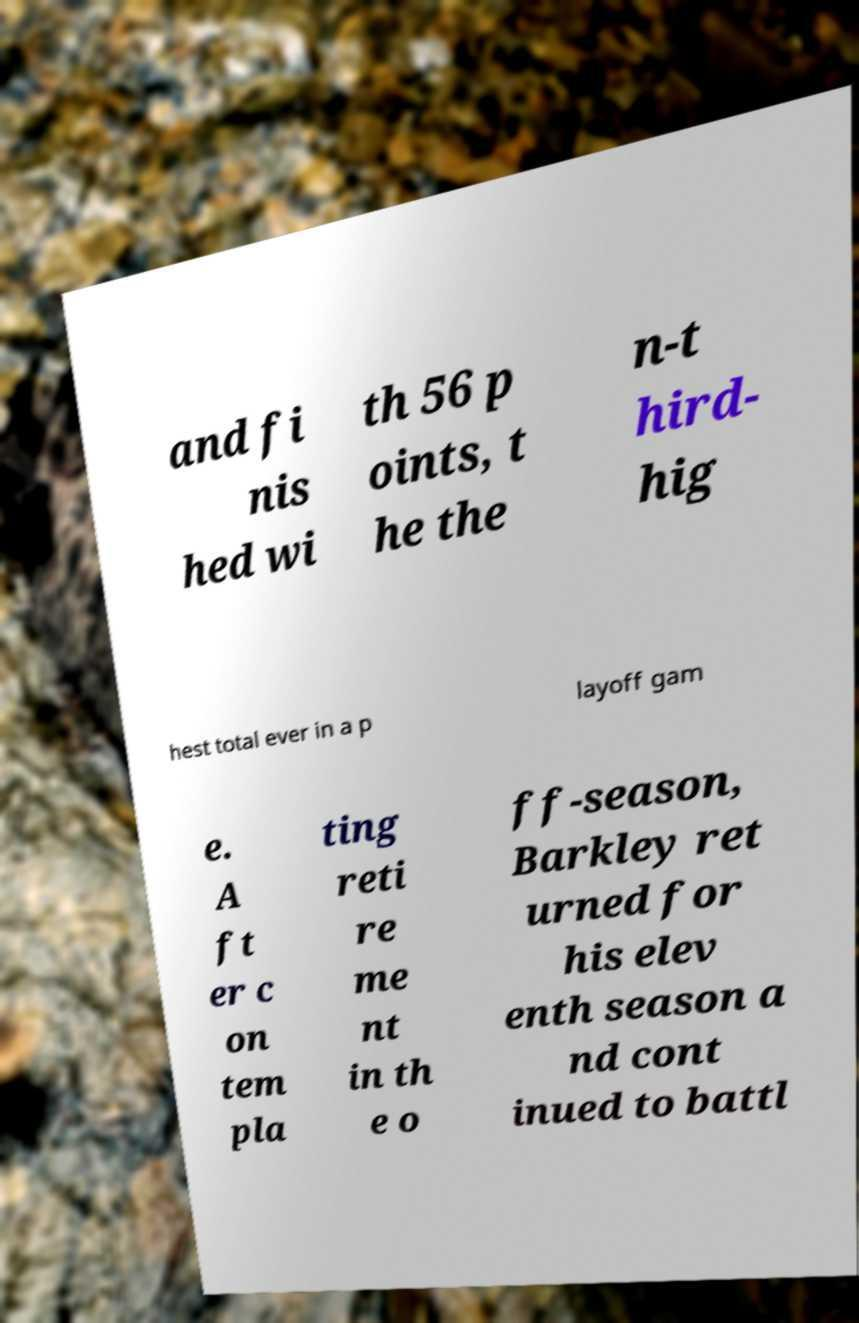Could you assist in decoding the text presented in this image and type it out clearly? and fi nis hed wi th 56 p oints, t he the n-t hird- hig hest total ever in a p layoff gam e. A ft er c on tem pla ting reti re me nt in th e o ff-season, Barkley ret urned for his elev enth season a nd cont inued to battl 